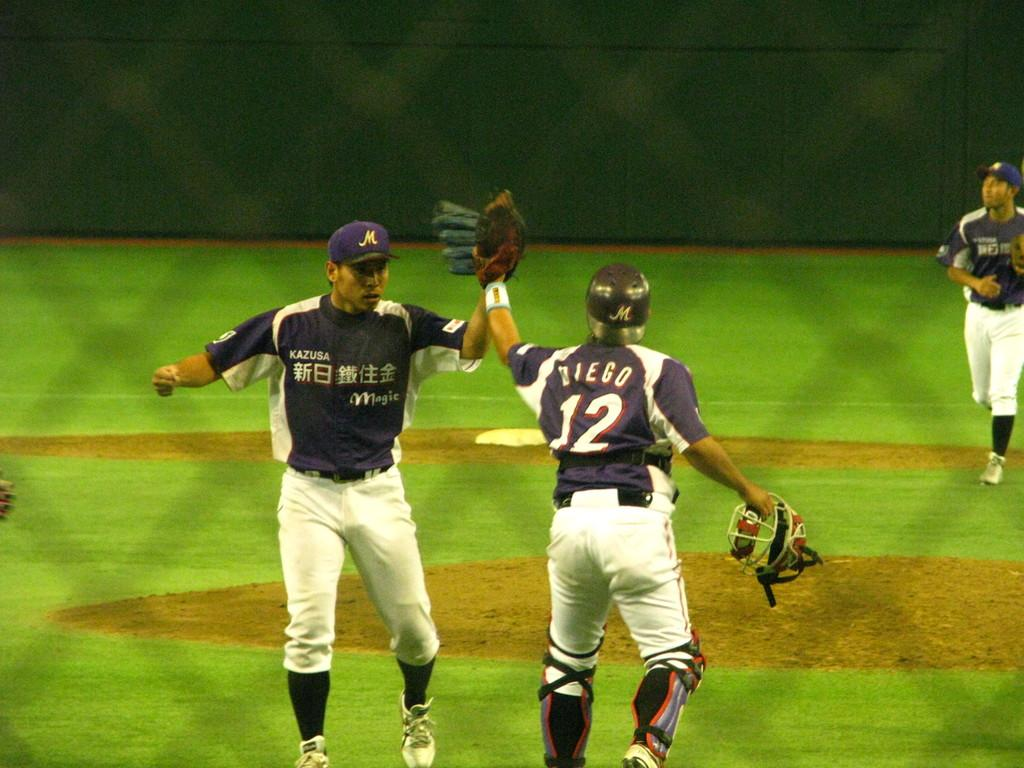Provide a one-sentence caption for the provided image. baseball player number 12 named diego taps gloves with another team player. 